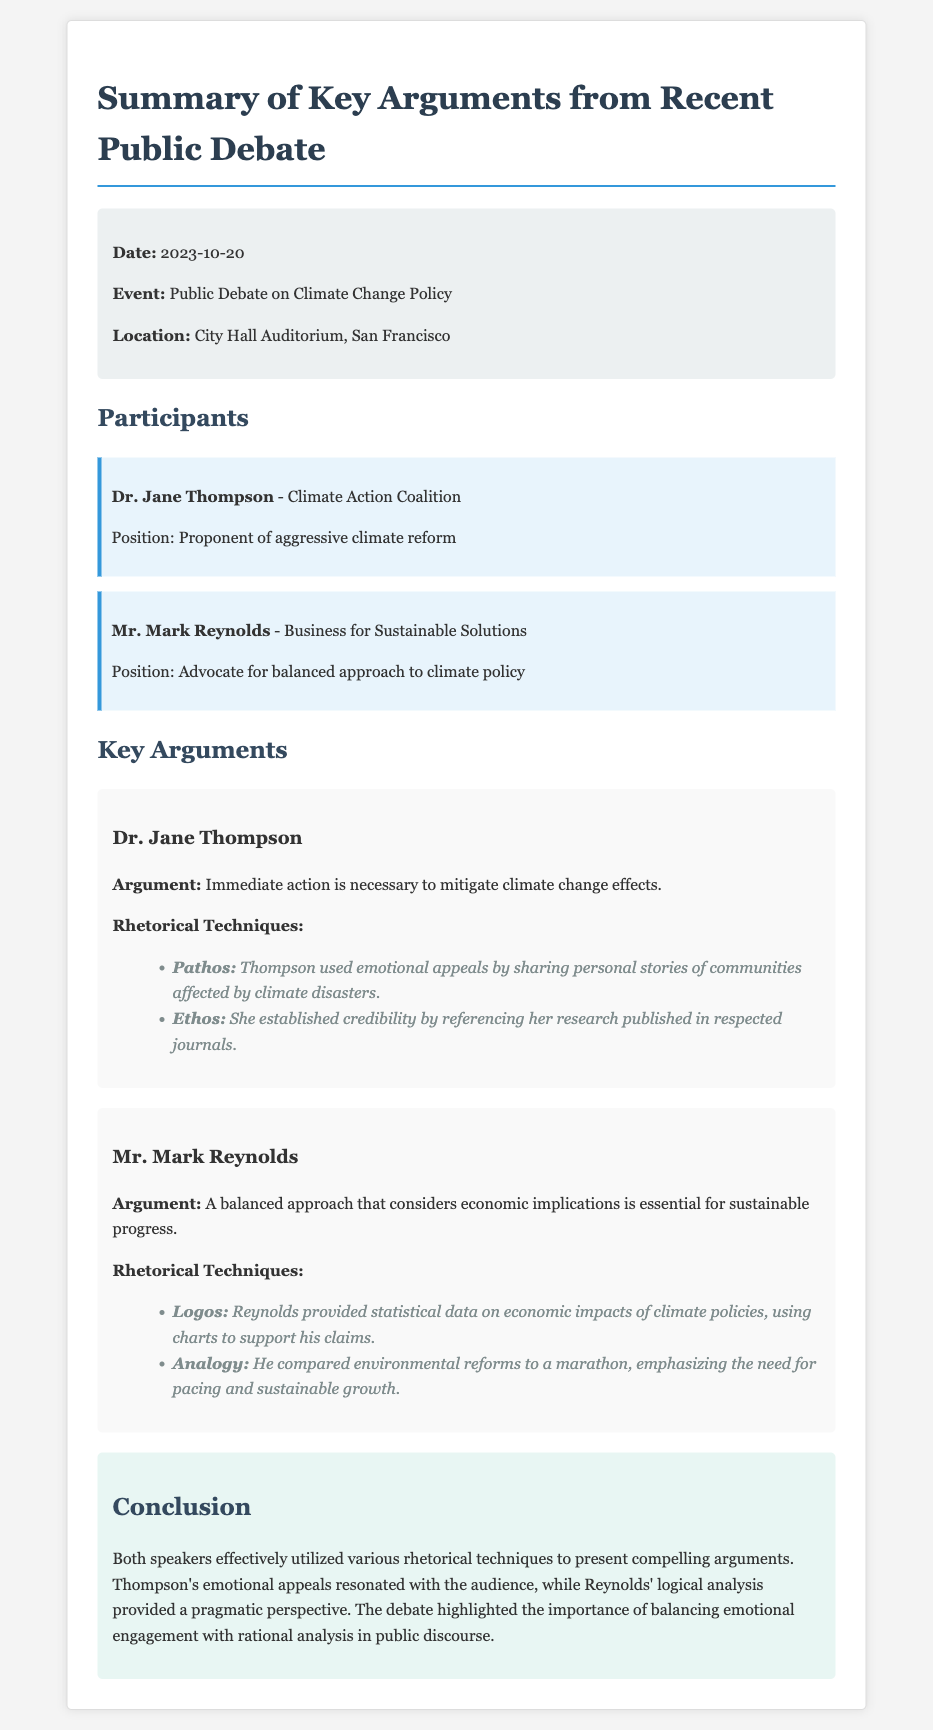What was the date of the debate? The date is specified in the event information section of the document.
Answer: 2023-10-20 Who represented the Climate Action Coalition? The participant section lists Dr. Jane Thompson as the representative of the Climate Action Coalition.
Answer: Dr. Jane Thompson What is Mr. Mark Reynolds' position? The document states that he is an advocate for a balanced approach to climate policy.
Answer: Advocate for balanced approach to climate policy Which rhetorical technique did Dr. Jane Thompson primarily use? The memo highlights her use of emotional appeals, particularly through personal stories related to climate disasters.
Answer: Pathos What analogy did Mr. Mark Reynolds use in his argument? The document mentions that he compared environmental reforms to a marathon, highlighting pacing.
Answer: Marathon How effective were the speakers' rhetorical techniques described in the conclusion? The conclusion evaluates the effectiveness of both speakers' techniques in their arguments.
Answer: Effective What type of event was discussed in the memo? The document specifies the event as a public debate on climate change policy.
Answer: Public Debate on Climate Change Policy What was one of the statistical tools used by Mr. Mark Reynolds? The memo states that he used charts to support his claims regarding economic impacts.
Answer: Charts 